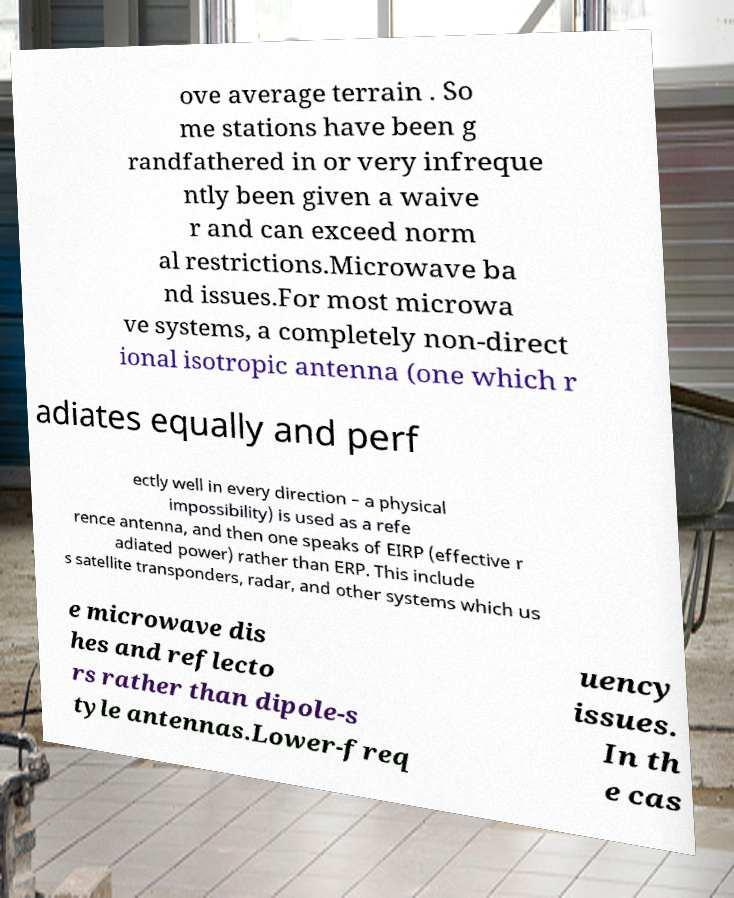Please identify and transcribe the text found in this image. ove average terrain . So me stations have been g randfathered in or very infreque ntly been given a waive r and can exceed norm al restrictions.Microwave ba nd issues.For most microwa ve systems, a completely non-direct ional isotropic antenna (one which r adiates equally and perf ectly well in every direction – a physical impossibility) is used as a refe rence antenna, and then one speaks of EIRP (effective r adiated power) rather than ERP. This include s satellite transponders, radar, and other systems which us e microwave dis hes and reflecto rs rather than dipole-s tyle antennas.Lower-freq uency issues. In th e cas 